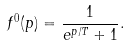<formula> <loc_0><loc_0><loc_500><loc_500>f ^ { 0 } ( p ) = \frac { 1 } { e ^ { p / T } + 1 } .</formula> 